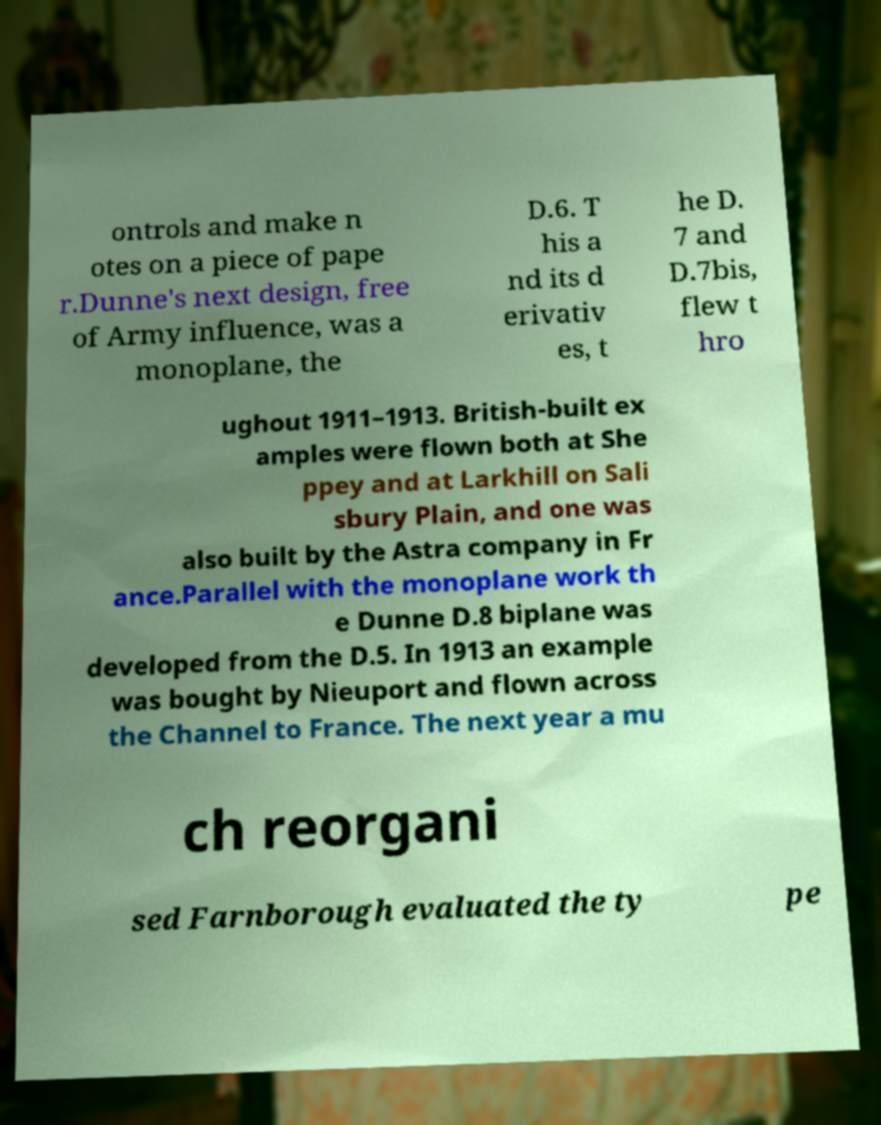Please read and relay the text visible in this image. What does it say? ontrols and make n otes on a piece of pape r.Dunne's next design, free of Army influence, was a monoplane, the D.6. T his a nd its d erivativ es, t he D. 7 and D.7bis, flew t hro ughout 1911–1913. British-built ex amples were flown both at She ppey and at Larkhill on Sali sbury Plain, and one was also built by the Astra company in Fr ance.Parallel with the monoplane work th e Dunne D.8 biplane was developed from the D.5. In 1913 an example was bought by Nieuport and flown across the Channel to France. The next year a mu ch reorgani sed Farnborough evaluated the ty pe 